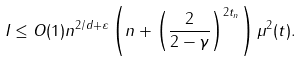<formula> <loc_0><loc_0><loc_500><loc_500>I \leq O ( 1 ) n ^ { 2 / d + \varepsilon } \left ( n + \left ( \frac { 2 } { 2 - \gamma } \right ) ^ { 2 t _ { n } } \right ) \mu ^ { 2 } ( t ) .</formula> 